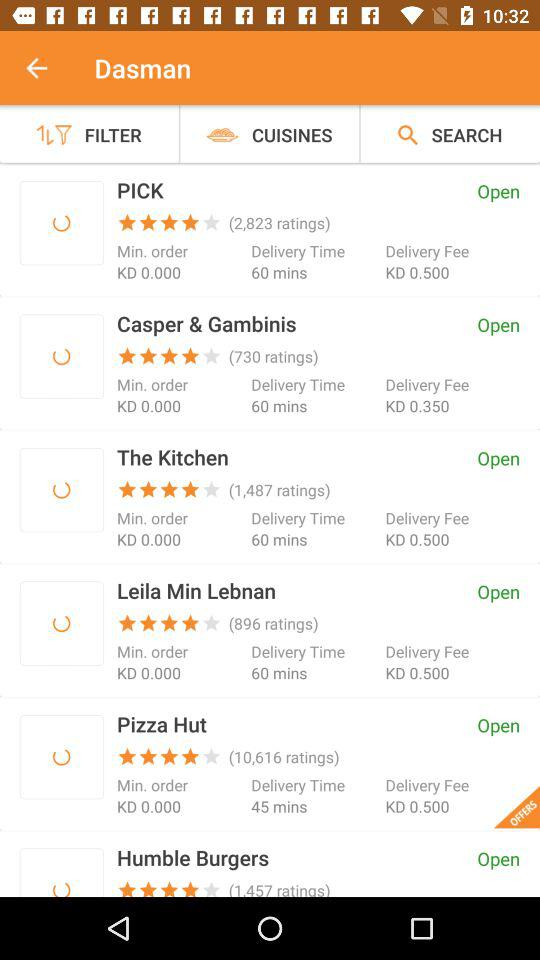Who got 730 ratings? 730 ratings were gotten by "Casper & Gambinis". 